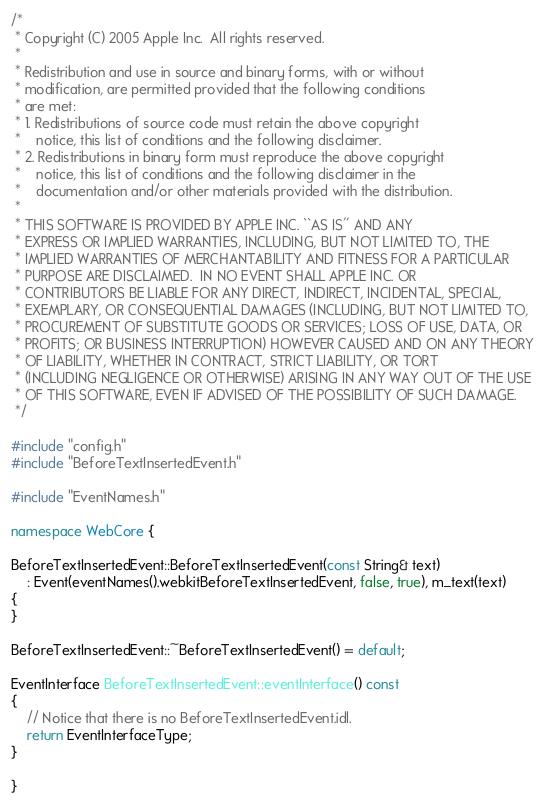<code> <loc_0><loc_0><loc_500><loc_500><_C++_>/*
 * Copyright (C) 2005 Apple Inc.  All rights reserved.
 *
 * Redistribution and use in source and binary forms, with or without
 * modification, are permitted provided that the following conditions
 * are met:
 * 1. Redistributions of source code must retain the above copyright
 *    notice, this list of conditions and the following disclaimer.
 * 2. Redistributions in binary form must reproduce the above copyright
 *    notice, this list of conditions and the following disclaimer in the
 *    documentation and/or other materials provided with the distribution.
 *
 * THIS SOFTWARE IS PROVIDED BY APPLE INC. ``AS IS'' AND ANY
 * EXPRESS OR IMPLIED WARRANTIES, INCLUDING, BUT NOT LIMITED TO, THE
 * IMPLIED WARRANTIES OF MERCHANTABILITY AND FITNESS FOR A PARTICULAR
 * PURPOSE ARE DISCLAIMED.  IN NO EVENT SHALL APPLE INC. OR
 * CONTRIBUTORS BE LIABLE FOR ANY DIRECT, INDIRECT, INCIDENTAL, SPECIAL,
 * EXEMPLARY, OR CONSEQUENTIAL DAMAGES (INCLUDING, BUT NOT LIMITED TO,
 * PROCUREMENT OF SUBSTITUTE GOODS OR SERVICES; LOSS OF USE, DATA, OR
 * PROFITS; OR BUSINESS INTERRUPTION) HOWEVER CAUSED AND ON ANY THEORY
 * OF LIABILITY, WHETHER IN CONTRACT, STRICT LIABILITY, OR TORT
 * (INCLUDING NEGLIGENCE OR OTHERWISE) ARISING IN ANY WAY OUT OF THE USE
 * OF THIS SOFTWARE, EVEN IF ADVISED OF THE POSSIBILITY OF SUCH DAMAGE. 
 */

#include "config.h"
#include "BeforeTextInsertedEvent.h"

#include "EventNames.h"

namespace WebCore {

BeforeTextInsertedEvent::BeforeTextInsertedEvent(const String& text)
    : Event(eventNames().webkitBeforeTextInsertedEvent, false, true), m_text(text)
{
}

BeforeTextInsertedEvent::~BeforeTextInsertedEvent() = default;

EventInterface BeforeTextInsertedEvent::eventInterface() const
{
    // Notice that there is no BeforeTextInsertedEvent.idl.
    return EventInterfaceType;
}

}
</code> 